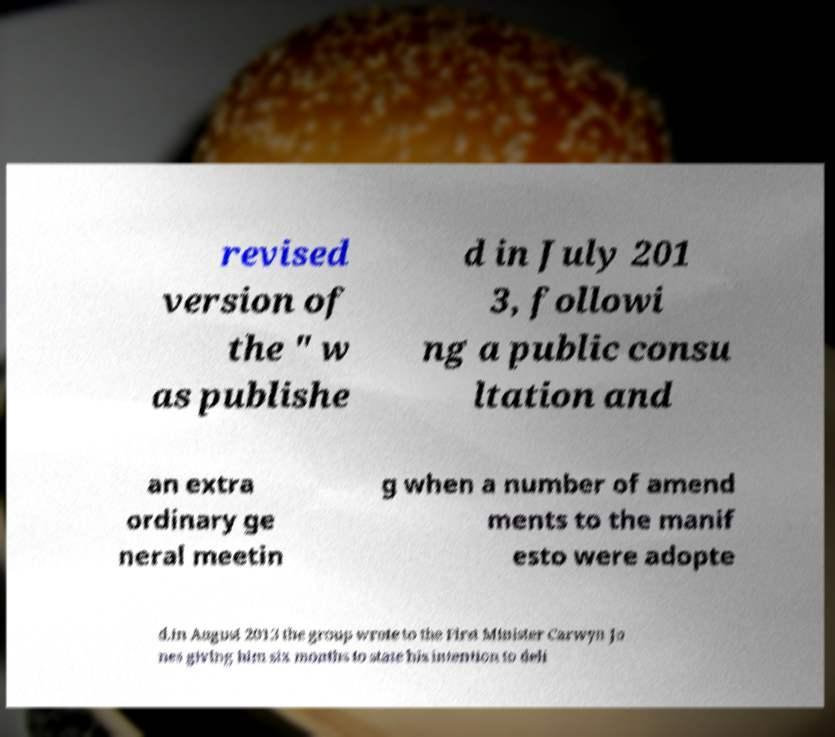Can you accurately transcribe the text from the provided image for me? revised version of the " w as publishe d in July 201 3, followi ng a public consu ltation and an extra ordinary ge neral meetin g when a number of amend ments to the manif esto were adopte d.In August 2013 the group wrote to the First Minister Carwyn Jo nes giving him six months to state his intention to deli 